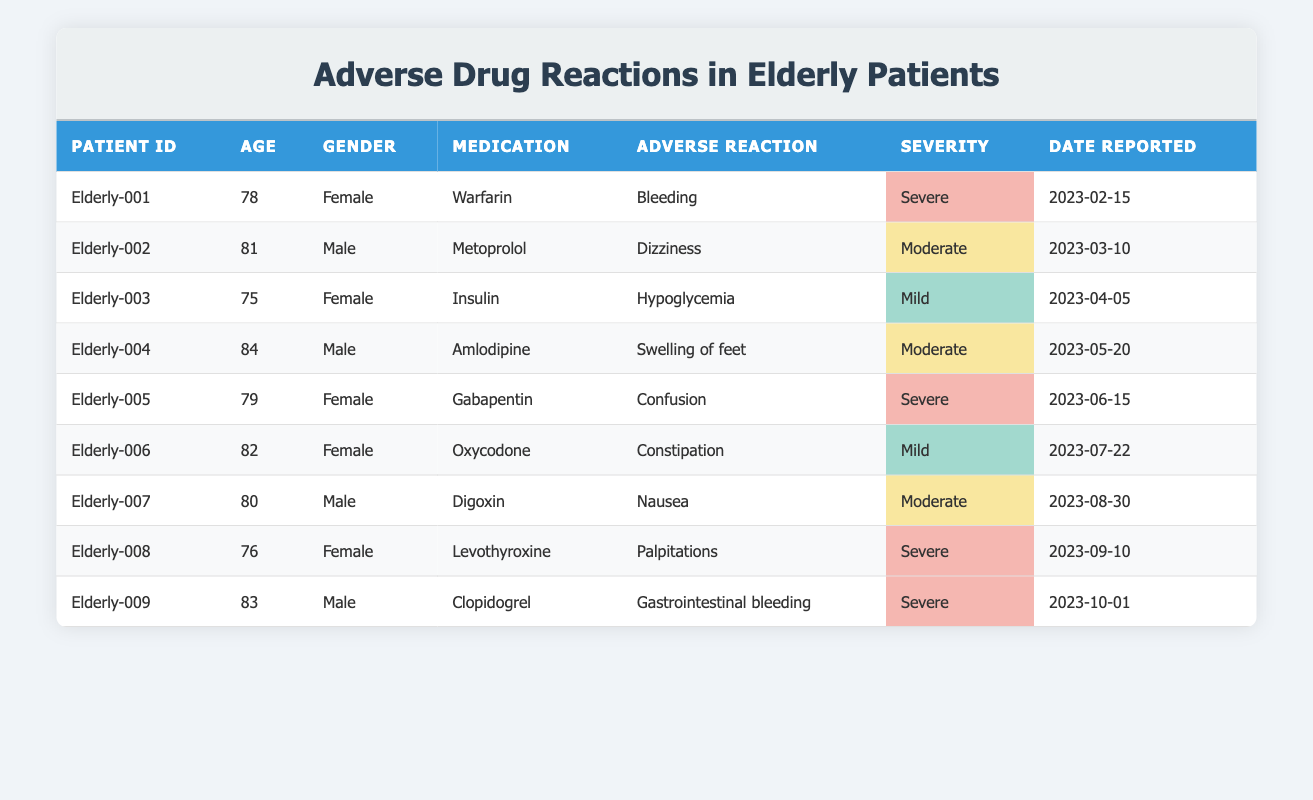What is the most common adverse reaction reported in the table? By reviewing the list of adverse reactions in the table, we see "Bleeding," "Dizziness," "Hypoglycemia," "Swelling of feet," "Confusion," "Constipation," "Nausea," "Palpitations," and "Gastrointestinal bleeding." However, none of these repeat. Since all adverse reactions are unique, none is more common than others.
Answer: None How many patients reported severe adverse reactions? We need to count the number of rows where the severity is marked as "Severe." Looking through the table, the following patients have severe reactions: Elderly-001 (Bleeding), Elderly-005 (Confusion), Elderly-008 (Palpitations), and Elderly-009 (Gastrointestinal bleeding) which totals to 4 patients.
Answer: 4 What percentage of adverse reactions reported are classified as mild? There are three mild reactions: Elderly-003 (Hypoglycemia), Elderly-006 (Constipation). With a total of 9 reactions, the calculation for the percentage is (2/9) * 100 = 22.22%.
Answer: 22.22% Is there any male patient who reported an adverse reaction to the medication Metoprolol? Looking through the table, we find that Eldery-002 (Age 81, Male) reported Dizziness as an adverse reaction to Metoprolol, confirming that yes, there is a male patient reporting an adverse reaction to this medication.
Answer: Yes What is the average age of patients who experienced severe adverse reactions? The patients experiencing severe reactions are Elderly-001 (78), Elderly-005 (79), Elderly-008 (76), and Elderly-009 (83). Adding their ages gives us 78 + 79 + 76 + 83 = 316. Divide this by 4 to find the average age: 316/4 = 79.
Answer: 79 Which medication had the least reported adverse reaction severity? Checking the severity ratings, mild reactions are assigned to Oxycodone (Constipation) and Insulin (Hypoglycemia). Since the "Least severe" refers to the mildest category, therefore both Insulin and Oxycodone tie for the least reported adverse reaction severity.
Answer: Insulin and Oxycodone How many total adverse reactions were reported in the table? To find the total number of adverse reactions, we count the rows in the table, which total to 9. This indicates there were 9 distinct adverse reactions reported.
Answer: 9 Is the adverse reaction of gastrointestinal bleeding reported in a patient aged above 80? Elderly-009 reported gastrointestinal bleeding and is aged 83. Since he is above 80, the answer is yes.
Answer: Yes Which gender experienced the most severe adverse reactions according to the table? By reviewing the severe adverse reactions, Elderly-001, Elderly-005, Elderly-008, and Elderly-009 include 3 females (Elderly-001, Elderly-005, Elderly-008) and 1 male (Elderly-009). Total male severe reactions are thus less than females. Therefore, females experienced more severe reactions.
Answer: Female 